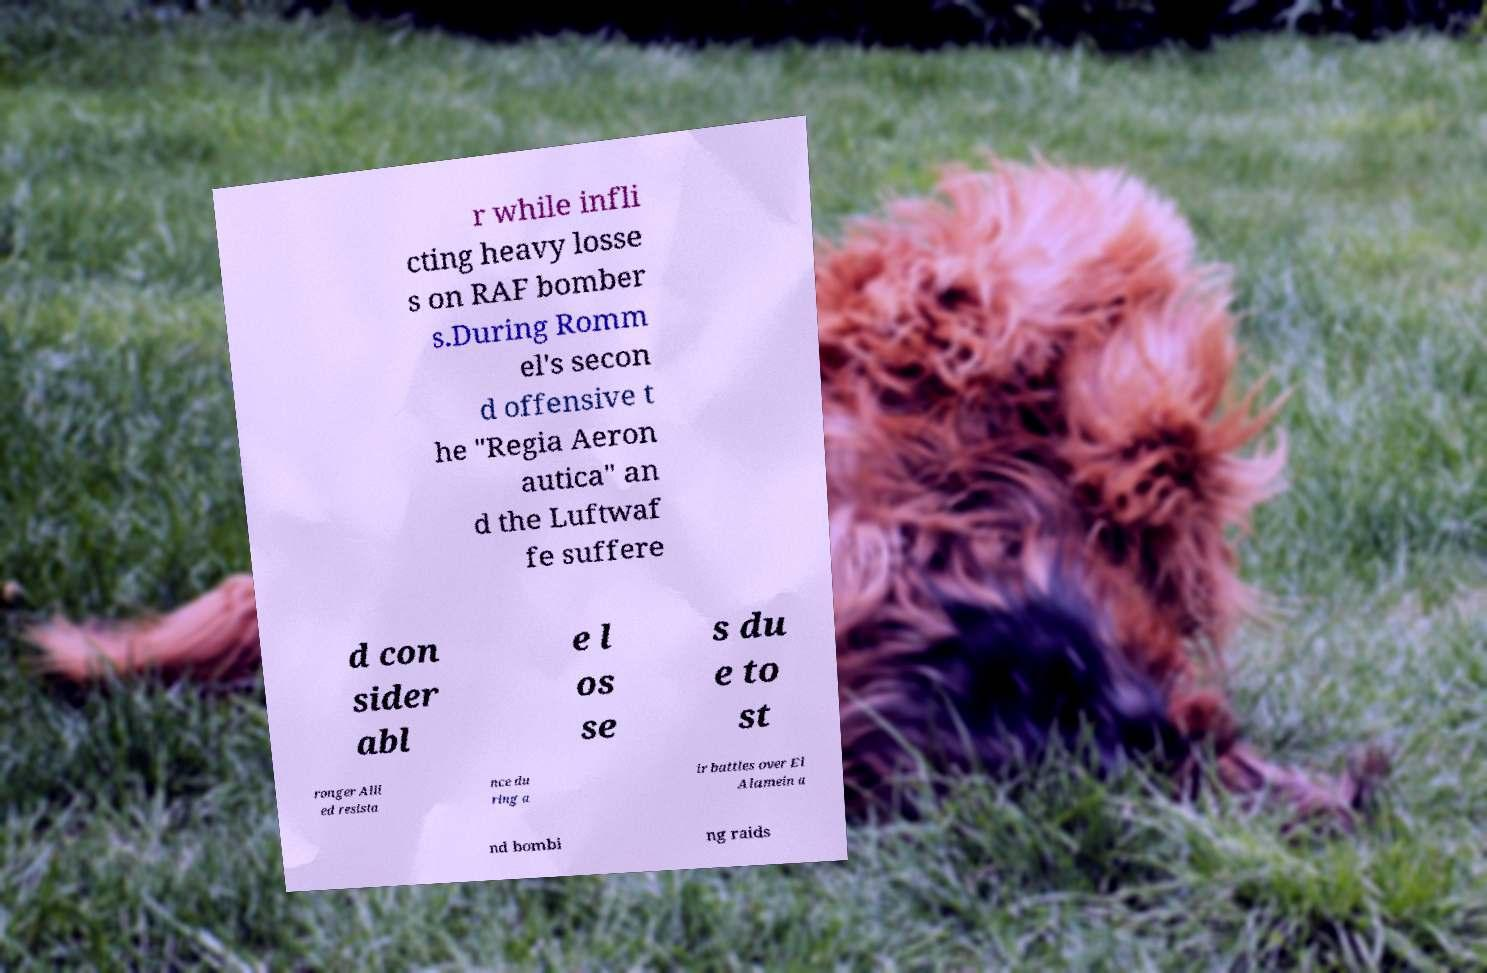Could you extract and type out the text from this image? r while infli cting heavy losse s on RAF bomber s.During Romm el's secon d offensive t he "Regia Aeron autica" an d the Luftwaf fe suffere d con sider abl e l os se s du e to st ronger Alli ed resista nce du ring a ir battles over El Alamein a nd bombi ng raids 